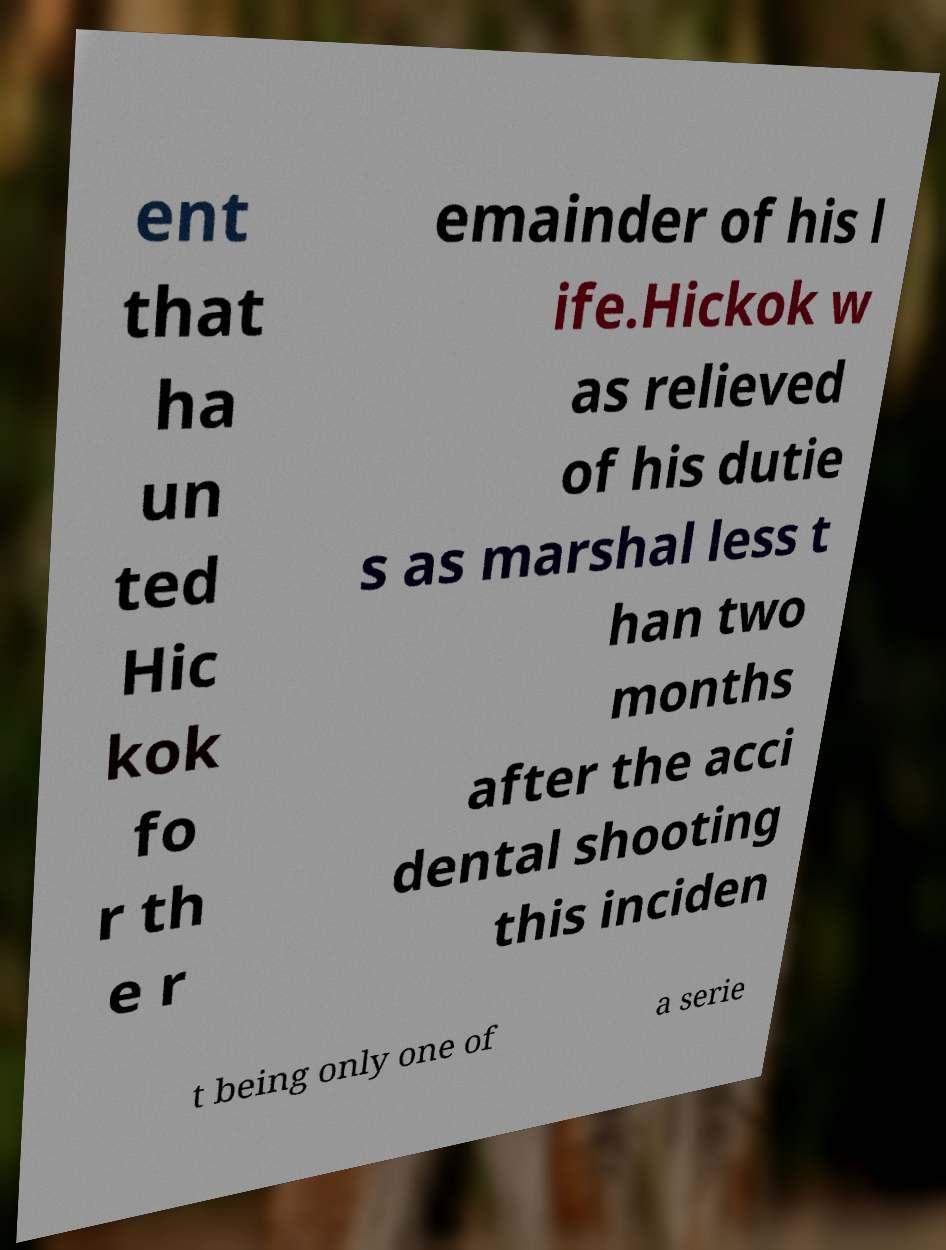Could you extract and type out the text from this image? ent that ha un ted Hic kok fo r th e r emainder of his l ife.Hickok w as relieved of his dutie s as marshal less t han two months after the acci dental shooting this inciden t being only one of a serie 